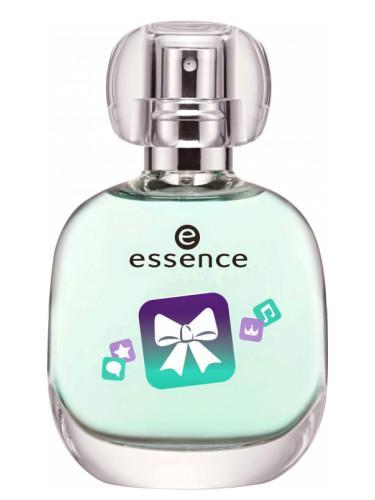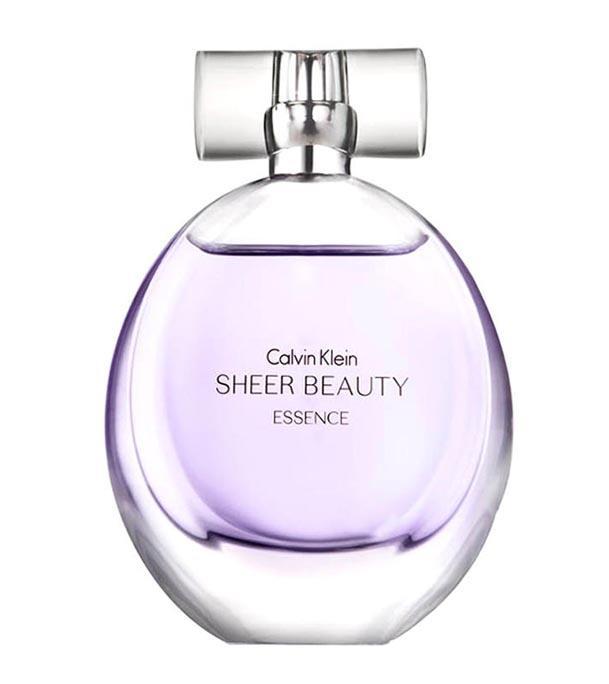The first image is the image on the left, the second image is the image on the right. Analyze the images presented: Is the assertion "the bottle on the right is pink." valid? Answer yes or no. No. 